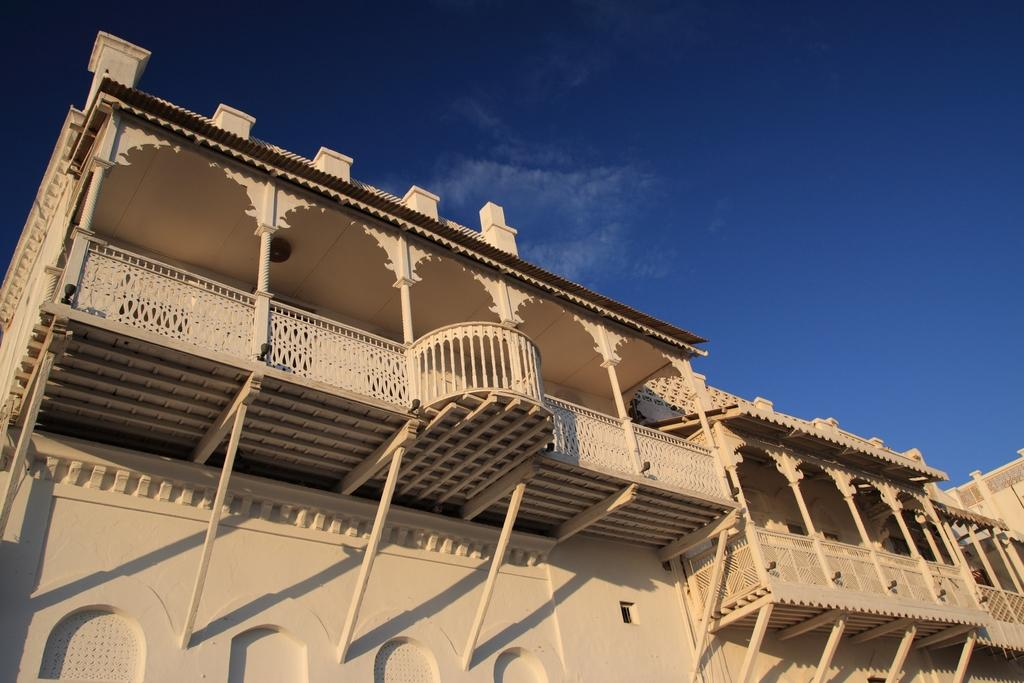What type of structures can be seen in the image? There are buildings in the image. What is the purpose of the barrier in the image? There is a fence in the image, which serves as a barrier or boundary. What part of the natural environment is visible in the image? The sky is visible in the image. How many rabbits can be seen hopping through the lumber in the image? There are no rabbits or lumber present in the image. 